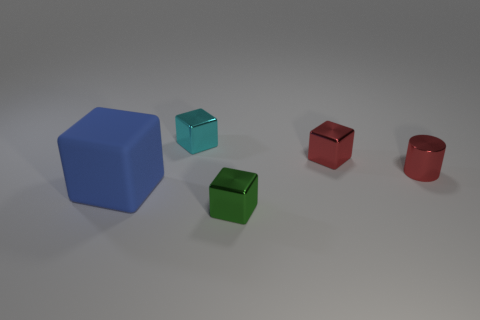There is a object to the left of the cyan cube; what is its color?
Keep it short and to the point. Blue. Are there an equal number of big blue objects in front of the large blue thing and large things?
Ensure brevity in your answer.  No. What is the shape of the metallic object that is in front of the cyan metallic thing and left of the red cube?
Keep it short and to the point. Cube. What is the color of the other large object that is the same shape as the green metallic thing?
Give a very brief answer. Blue. Are there any other things that have the same color as the matte object?
Provide a succinct answer. No. What is the shape of the tiny red metal object that is behind the thing that is right of the red metallic object on the left side of the red metallic cylinder?
Your answer should be compact. Cube. There is a cube in front of the big blue cube; does it have the same size as the object that is on the left side of the cyan metal thing?
Provide a short and direct response. No. How many other tiny green objects are made of the same material as the tiny green object?
Your answer should be compact. 0. What number of blue matte cubes are on the left side of the cube that is to the right of the tiny thing that is in front of the rubber thing?
Offer a very short reply. 1. Is the big blue object the same shape as the small cyan metallic thing?
Your answer should be very brief. Yes. 